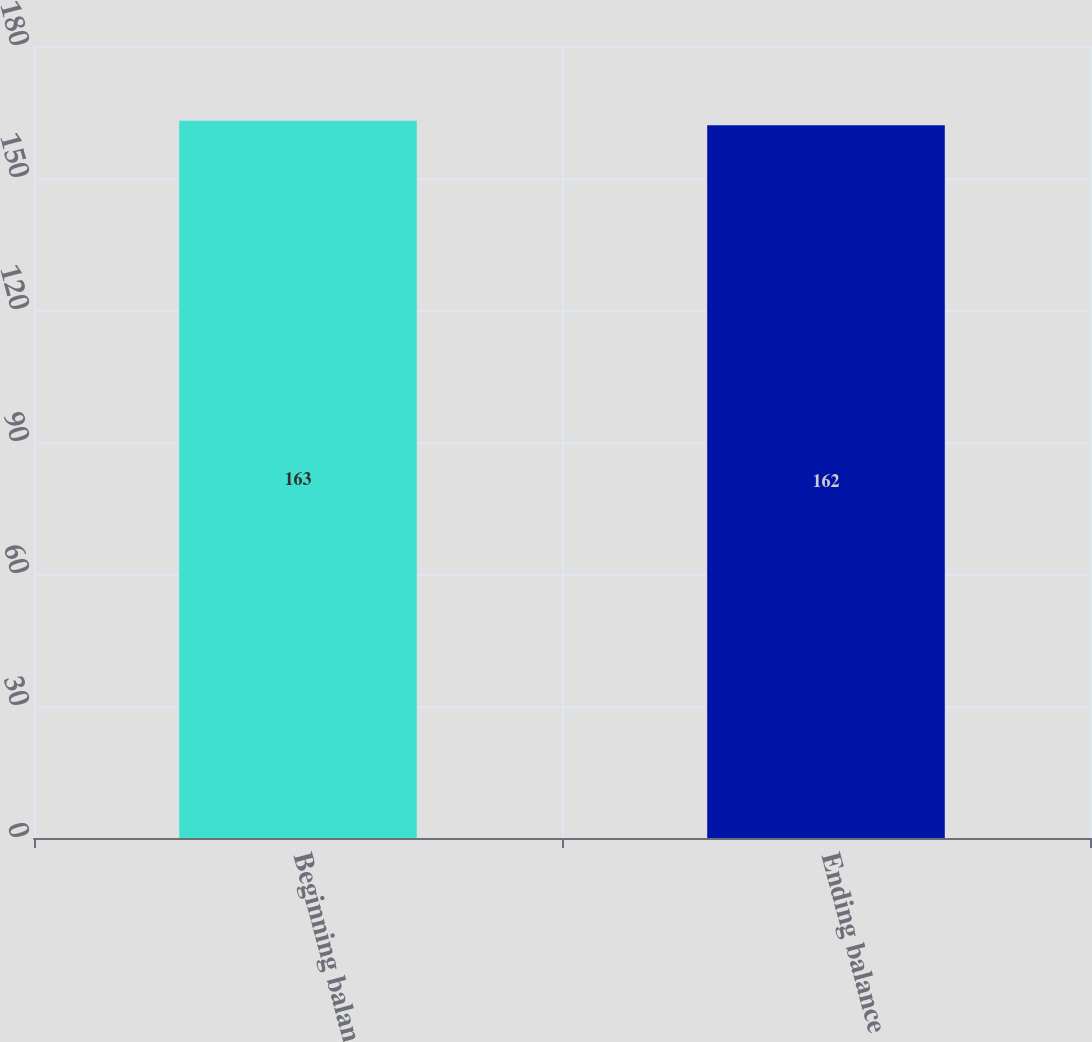Convert chart to OTSL. <chart><loc_0><loc_0><loc_500><loc_500><bar_chart><fcel>Beginning balance<fcel>Ending balance<nl><fcel>163<fcel>162<nl></chart> 